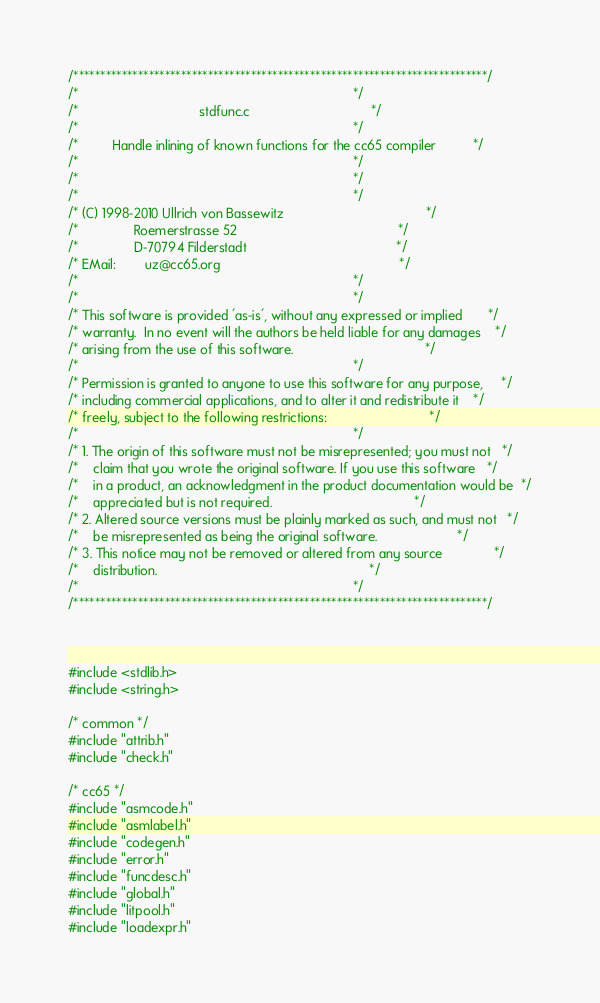Convert code to text. <code><loc_0><loc_0><loc_500><loc_500><_C_>/*****************************************************************************/
/*                                                                           */
/*                                 stdfunc.c                                 */
/*                                                                           */
/*         Handle inlining of known functions for the cc65 compiler          */
/*                                                                           */
/*                                                                           */
/*                                                                           */
/* (C) 1998-2010 Ullrich von Bassewitz                                       */
/*               Roemerstrasse 52                                            */
/*               D-70794 Filderstadt                                         */
/* EMail:        uz@cc65.org                                                 */
/*                                                                           */
/*                                                                           */
/* This software is provided 'as-is', without any expressed or implied       */
/* warranty.  In no event will the authors be held liable for any damages    */
/* arising from the use of this software.                                    */
/*                                                                           */
/* Permission is granted to anyone to use this software for any purpose,     */
/* including commercial applications, and to alter it and redistribute it    */
/* freely, subject to the following restrictions:                            */
/*                                                                           */
/* 1. The origin of this software must not be misrepresented; you must not   */
/*    claim that you wrote the original software. If you use this software   */
/*    in a product, an acknowledgment in the product documentation would be  */
/*    appreciated but is not required.                                       */
/* 2. Altered source versions must be plainly marked as such, and must not   */
/*    be misrepresented as being the original software.                      */
/* 3. This notice may not be removed or altered from any source              */
/*    distribution.                                                          */
/*                                                                           */
/*****************************************************************************/



#include <stdlib.h>
#include <string.h>

/* common */
#include "attrib.h"
#include "check.h"

/* cc65 */
#include "asmcode.h"
#include "asmlabel.h"
#include "codegen.h"
#include "error.h"
#include "funcdesc.h"
#include "global.h"
#include "litpool.h"
#include "loadexpr.h"</code> 